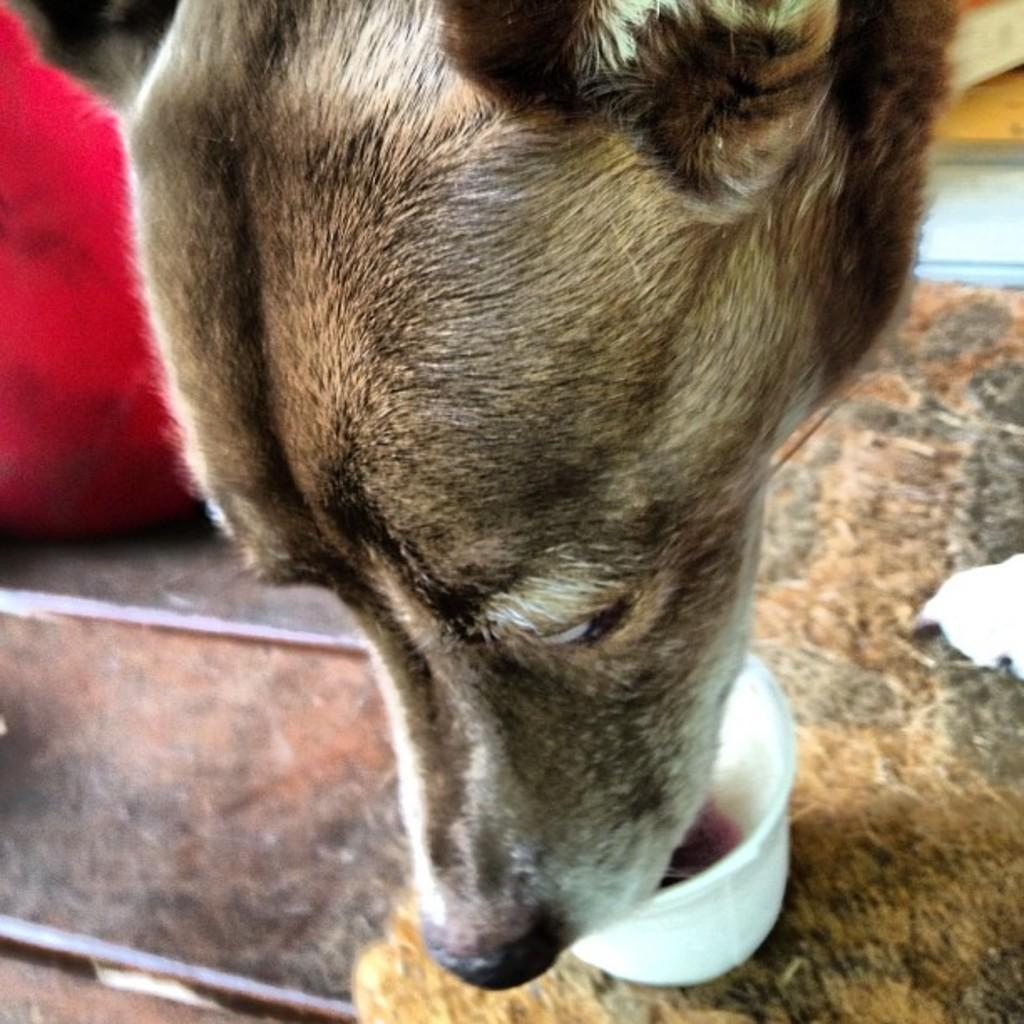What animal can be seen in the image? There is a dog in the image. What is the dog doing in the image? The dog is eating food in the image. How is the dog's food presented? The food is placed in a bowl. What color is the cloth on the floor in the image? The cloth on the floor is pink. Where is the vase placed in the image? There is no vase present in the image. How does the dog grip the food while eating in the image? The image does not show the dog's grip on the food, but it can be assumed that the dog is using its mouth to eat. 